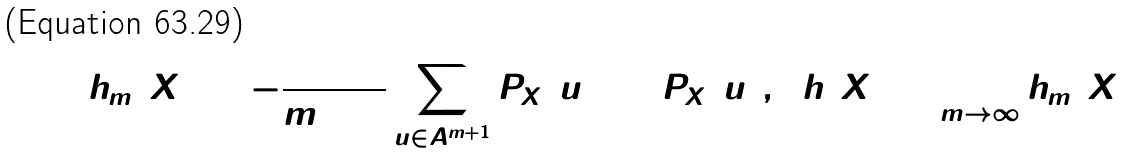<formula> <loc_0><loc_0><loc_500><loc_500>h _ { m } ( X ) = - \frac { 1 } { m + 1 } \sum _ { u \in A ^ { m + 1 } } P _ { X } ( u ) \log P _ { X } ( u ) , \ \ h ( X ) = \lim _ { m \rightarrow \infty } h _ { m } ( X )</formula> 